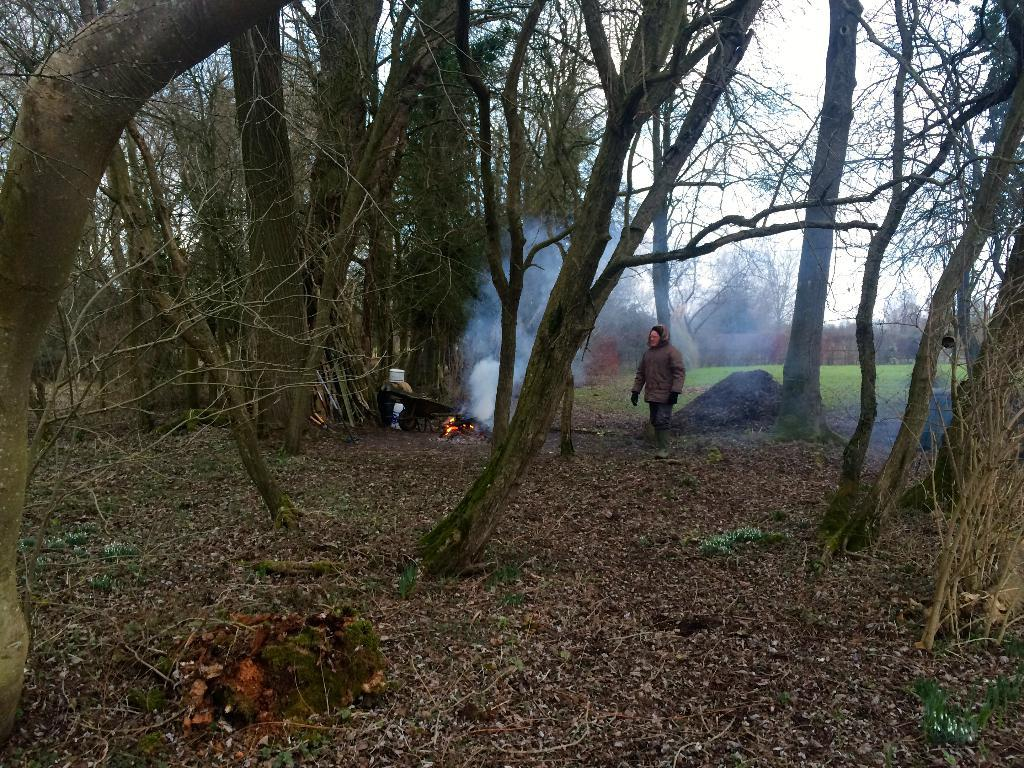What is the person in the image doing? There is a person on the ground in the image. What is the source of the smoke in the image? There is fire with smoke in the image. What type of vegetation is present in the image? There is grass and dried leaves in the image. What objects can be seen in the image? There are objects visible in the image. What is visible in the background of the image? There are trees and the sky in the background of the image. What type of clock is visible in the image? There is no clock present in the image. What letters are being spelled out by the person in the image? There are no letters or any indication of spelling in the image. 